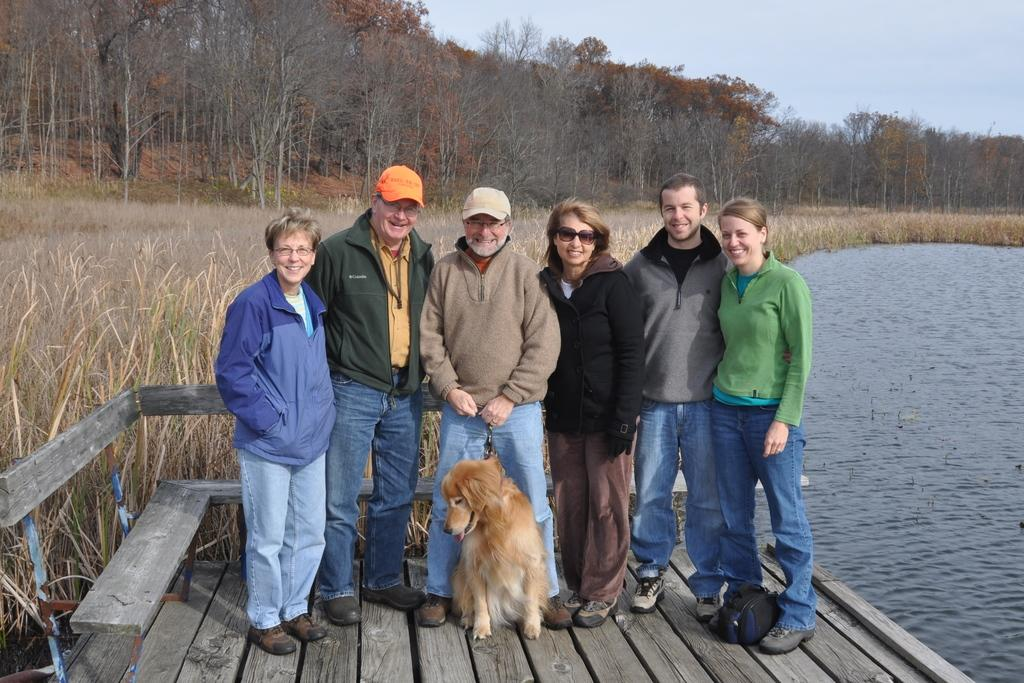What are the people doing on the wooden platform in the image? The people are standing on the wooden platform in the image. What type of animal is with the people? A dog is present with the people. What is the facial expression of the people in the image? The people are smiling in the image. What can be seen in the background of the image? There are trees, water, and grass visible in the background of the image. Reasoning: Let's think step by step by breaking down the facts into individual elements. We start by identifying the main subjects in the image, which are the people and the dog. Then, we describe their actions and expressions, noting that they are standing on a wooden platform and smiling. Next, we describe the background, which includes trees, water, and grass. Each question is designed to elicit a specific detail about the image that is known from the provided facts. Absurd Question/Answer: What type of polish is being applied to the dog's fur in the image? There is no indication in the image that any polish is being applied to the dog's fur. 